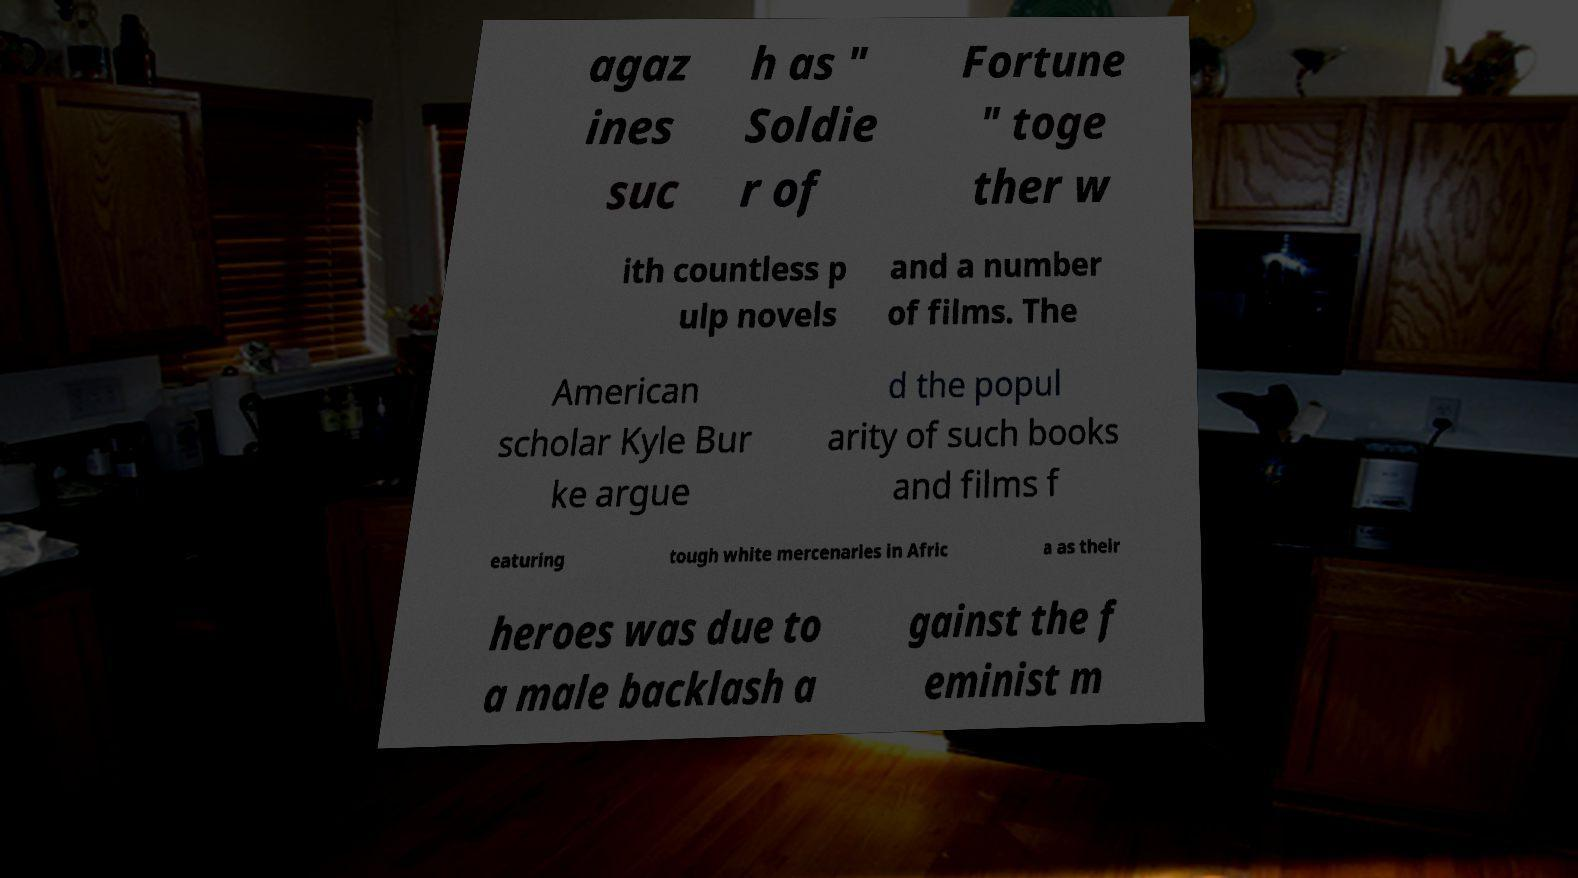Could you extract and type out the text from this image? agaz ines suc h as " Soldie r of Fortune " toge ther w ith countless p ulp novels and a number of films. The American scholar Kyle Bur ke argue d the popul arity of such books and films f eaturing tough white mercenaries in Afric a as their heroes was due to a male backlash a gainst the f eminist m 